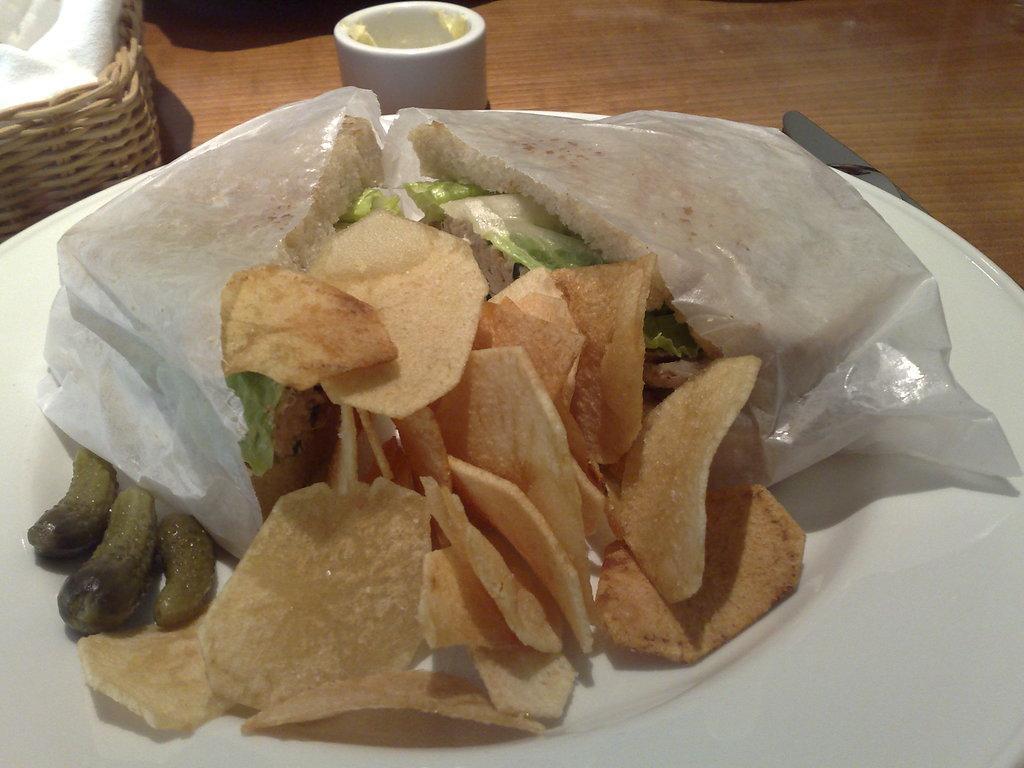Could you give a brief overview of what you see in this image? In this image there is a table with a cup of butter, a basket with a cloth and a plate with a few chips, cucumbers and a sandwich on it. 